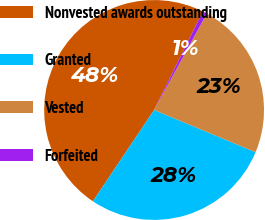Convert chart to OTSL. <chart><loc_0><loc_0><loc_500><loc_500><pie_chart><fcel>Nonvested awards outstanding<fcel>Granted<fcel>Vested<fcel>Forfeited<nl><fcel>47.92%<fcel>28.12%<fcel>23.31%<fcel>0.65%<nl></chart> 